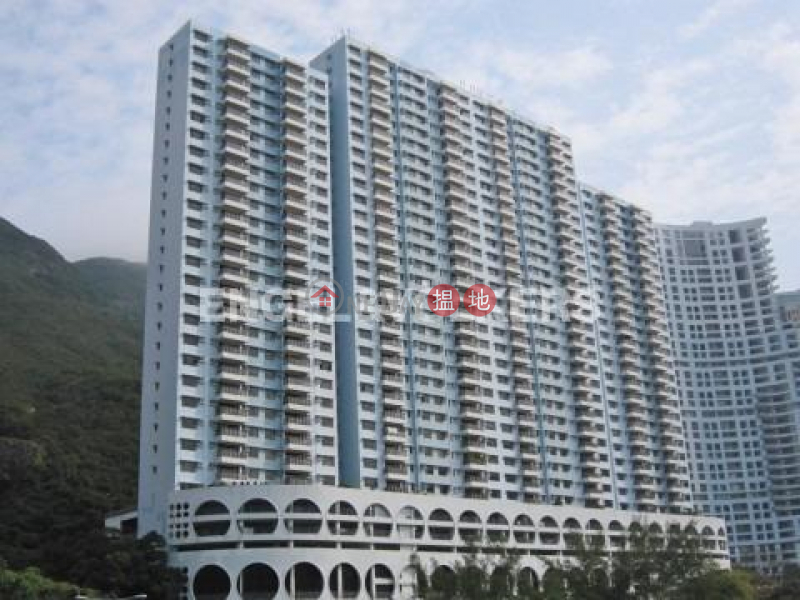Can you describe how the architectural design might be influenced by the local climate? The architectural design of the building, featuring extensive balconies and large windows, suggests an adaptation to a warmer climate, possibly aiming to maximize natural ventilation and outdoor living spaces. This is common in regions where residents can enjoy the outside air for most of the year without the discomfort of extreme temperatures. The use of lighter colors in the building's facade could also reflect sunlight to help keep interiors cooler. 